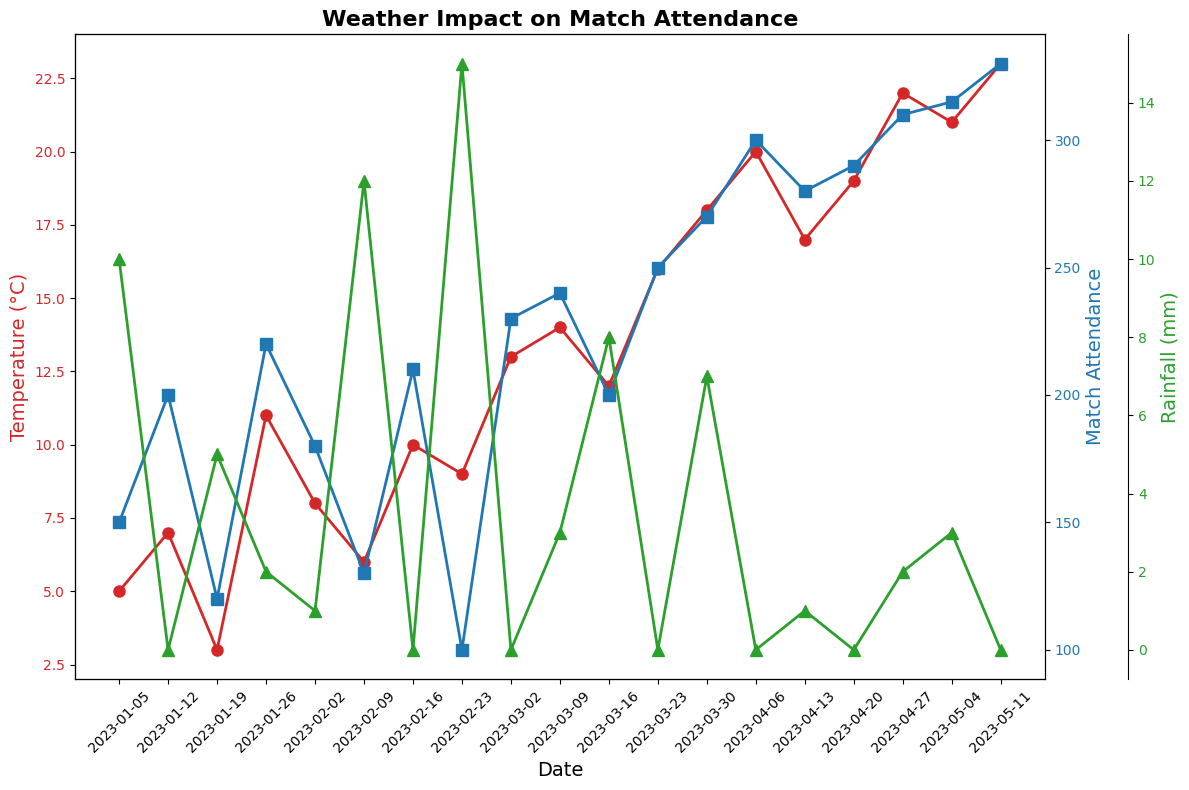What general trend do you see in match attendance as the temperature increases? Attendance generally increases as the temperature increases, particularly noticeable from the date range in April to May, where higher temperatures correspond to higher attendance.
Answer: Increases On which date was the highest match attendance recorded, and what was the temperature and rainfall on that day? The highest match attendance is indicated by the peak blue line at the end, corresponding to May 11, with an attendance of 330. The temperature was 23°C, and there was no rainfall.
Answer: May 11; 23°C; 0 mm How does match attendance on days with no rainfall compare to days with rain? By observing the blue and green lines, attendance is generally higher on days with no rainfall. For example, comparing data points such as Mar 23 with 0 mm and 250 attendance vs Mar 30 with 7 mm and 270 attendance, no-rainfall days generally see higher attendance except some instances.
Answer: Higher on no-rainfall days What is the average temperature on days when attendance was over 250? Determine the days with attendance above 250: Mar 30, Apr 6, Apr 13, Apr 20, Apr 27, May 4, May 11. The respective temperatures are 18, 20, 17, 19, 22, 21, 23. Calculate the average: (18 + 20 + 17 + 19 + 22 + 21 + 23) / 7 = 20
Answer: 20°C Which day had the lowest attendance, and what were the weather conditions on that day? The lowest attendance is indicated by the lowest point on the blue line, corresponding to Feb 23, with an attendance of 100. The temperature was 9°C, and rainfall was 15 mm.
Answer: Feb 23; 9°C; 15 mm Is there any day where high rainfall is associated with high attendance? Examine the figure for high green peaks (rainfall) and corresponding blue points (attendance). On Mar 30, there was high rainfall (7 mm) and high attendance (270).
Answer: Mar 30 What is the correlation between temperature and match attendance during months with warm weather? Look at the warmer months (April-May) where temperatures are generally above 15°C that show a high temperature corresponding to high match attendance. Most of these days, higher temperature directly relates to higher match attendance.
Answer: Positive correlation On which date did a drop in temperature coincide with a drop in attendance and what amount of rainfall was there? Observe the figure for drops. For instance, Jan 19 shows a temperature drop (3°C) and a corresponding drop in attendance (120). On this date, it also rained 5 mm.
Answer: Jan 19; 5 mm 